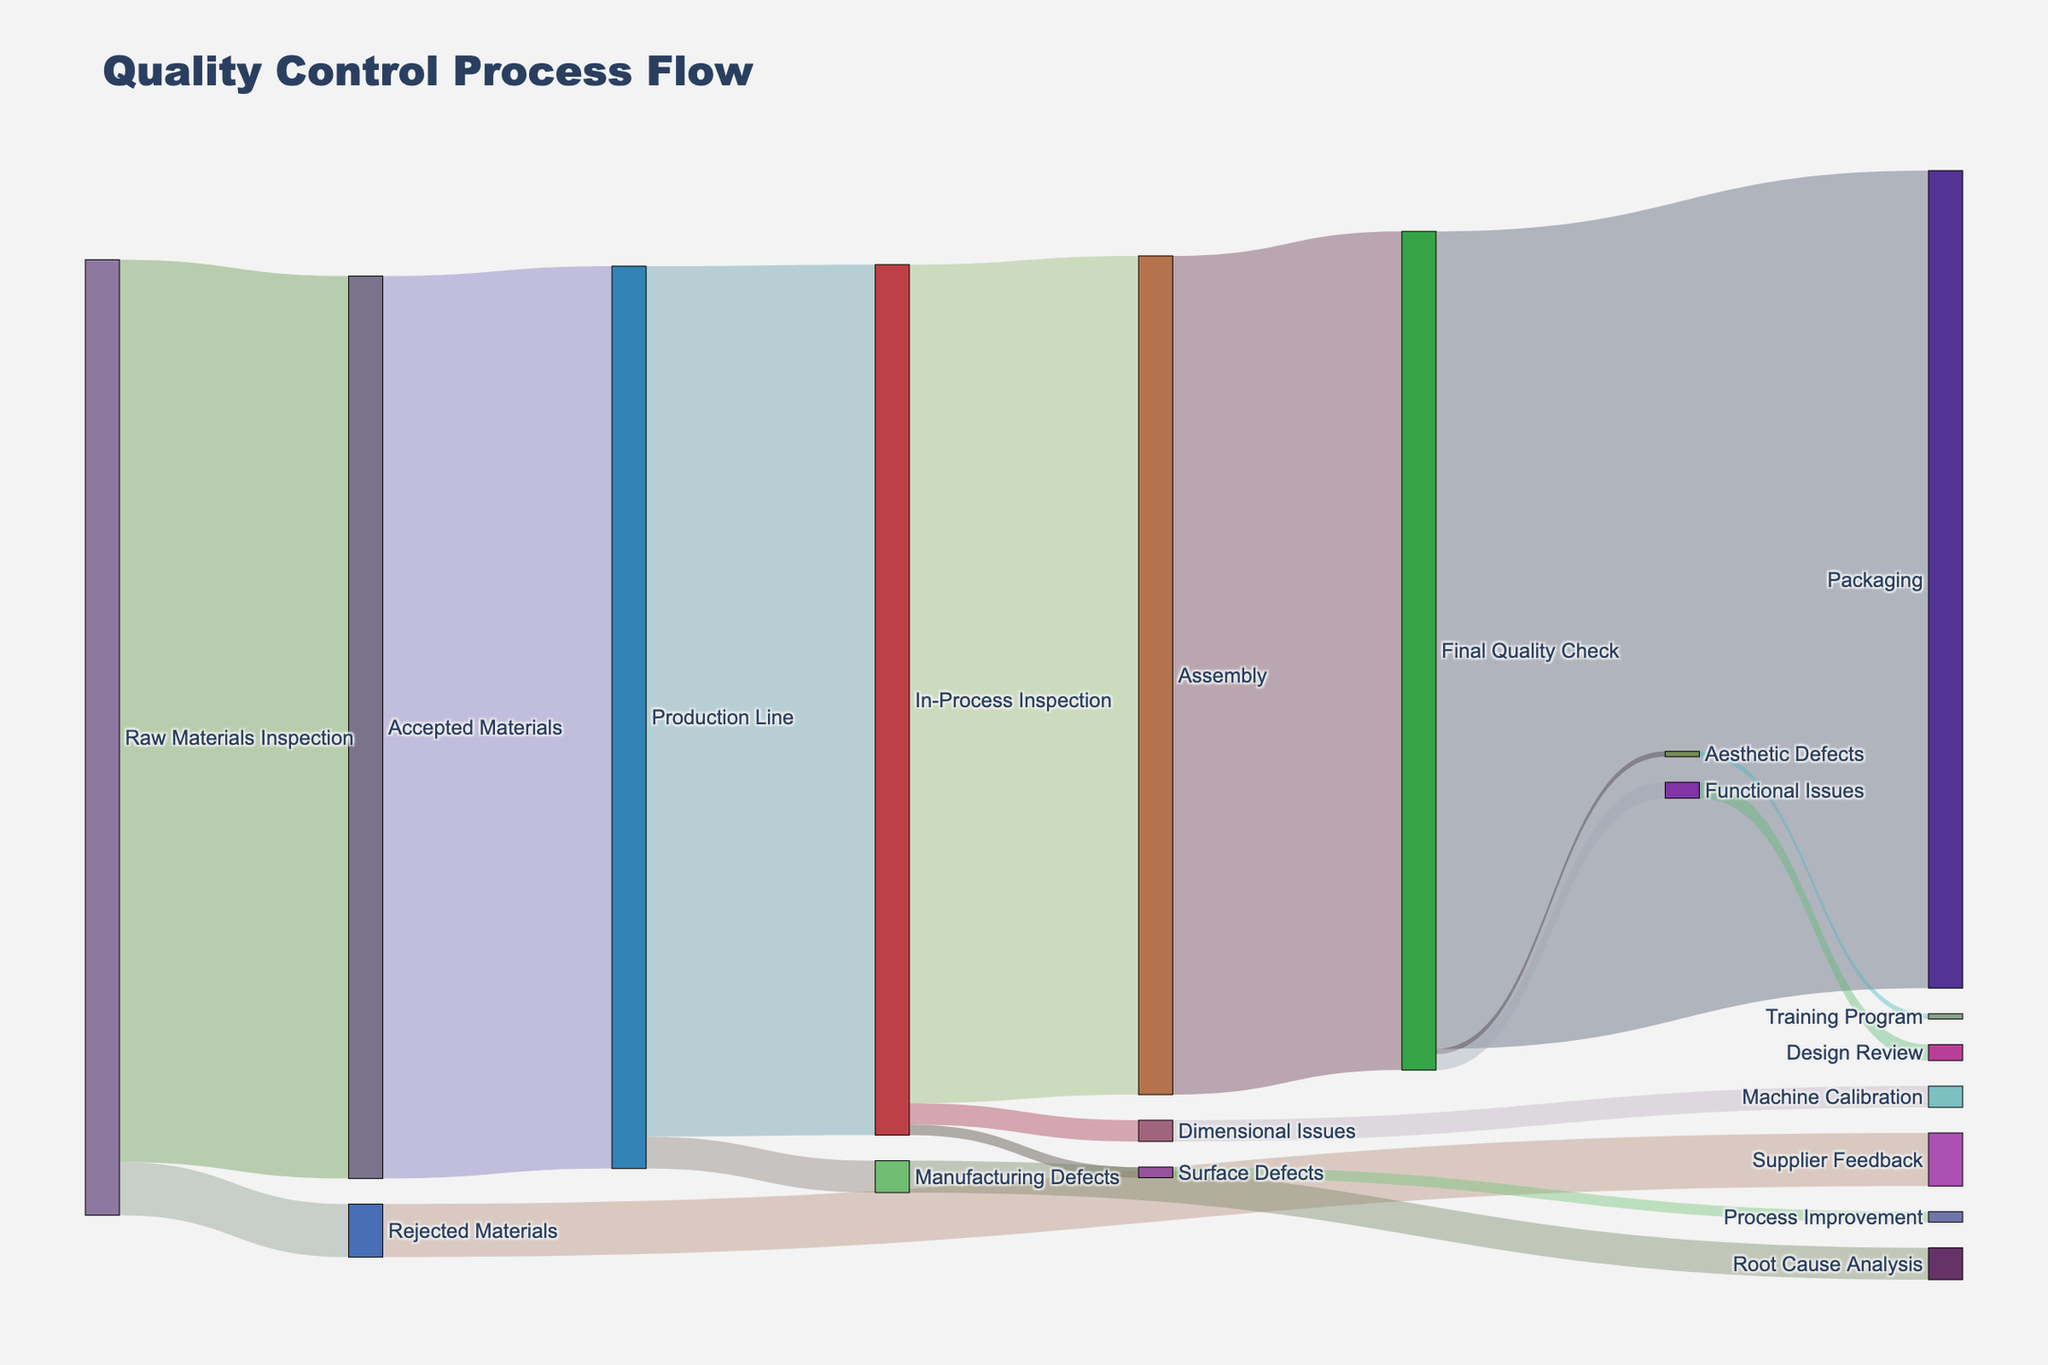How many stages are there in the entire quality control process? There are nodes in the Sankey diagram representing different stages. These include "Raw Materials Inspection," "Accepted Materials," "Production Line," "In-Process Inspection," "Assembly," "Final Quality Check," and "Packaging." Counting these nodes gives us the number of stages in the process.
Answer: 7 What is the flow value from Raw Materials Inspection to Rejected Materials? To find this, we look at the link from "Raw Materials Inspection" to "Rejected Materials" in the Sankey diagram, which has a corresponding flow value.
Answer: 500 Which stage receives the highest amount of accepted material? By comparing the values received by each stage, "Production Line" receives 8500 units, which is the highest amount of accepted material from "Accepted Materials."
Answer: Production Line What is the combined flow value of defects identified during the In-Process Inspection? To find this, we sum up the values of "Dimensional Issues" (200) and "Surface Defects" (100), which result from the In-Process Inspection.
Answer: 300 How does the number of units in Assembly compare to the number of units in Final Quality Check? We check the flow values entering "Assembly" and "Final Quality Check." Both stages receive 7900 units. Since the numbers are the same, the comparison shows they are equal.
Answer: Equal From which stage do the rejected materials originate, and what is their resultant corrective action? Observing the Sankey diagram, "Rejected Materials" originate from "Raw Materials Inspection" with a value of 500, leading to "Supplier Feedback."
Answer: Raw Materials Inspection, Supplier Feedback Which defect type in the Final Quality Check has the smallest flow value, and what corrective action is taken? Comparing the flow values of defect types in "Final Quality Check," "Aesthetic Defects" has the smallest flow value of 50, leading to the corrective action "Training Program."
Answer: Aesthetic Defects, Training Program What is the total number of units that undergo a corrective action? Summing the corrective actions for all defects: "Supplier Feedback" (500), "Root Cause Analysis" (300), "Machine Calibration" (200), "Process Improvement" (100), "Design Review" (150), and "Training Program" (50). Adding these gives us the total number of units.
Answer: 1300 